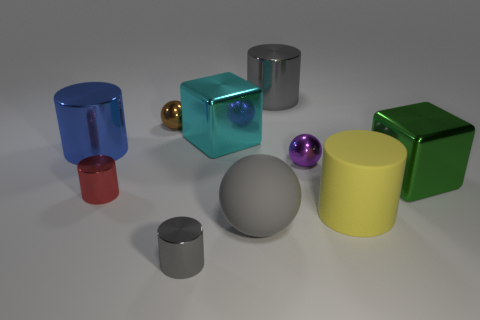Subtract all yellow cylinders. How many cylinders are left? 4 Subtract all red cylinders. How many cylinders are left? 4 Subtract all green spheres. Subtract all brown cylinders. How many spheres are left? 3 Subtract all spheres. How many objects are left? 7 Add 3 big balls. How many big balls exist? 4 Subtract 0 red spheres. How many objects are left? 10 Subtract all metal objects. Subtract all yellow things. How many objects are left? 1 Add 1 large cylinders. How many large cylinders are left? 4 